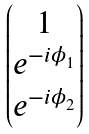<formula> <loc_0><loc_0><loc_500><loc_500>\begin{pmatrix} 1 \\ e ^ { - i \phi _ { 1 } } \\ e ^ { - i \phi _ { 2 } } \\ \end{pmatrix}</formula> 